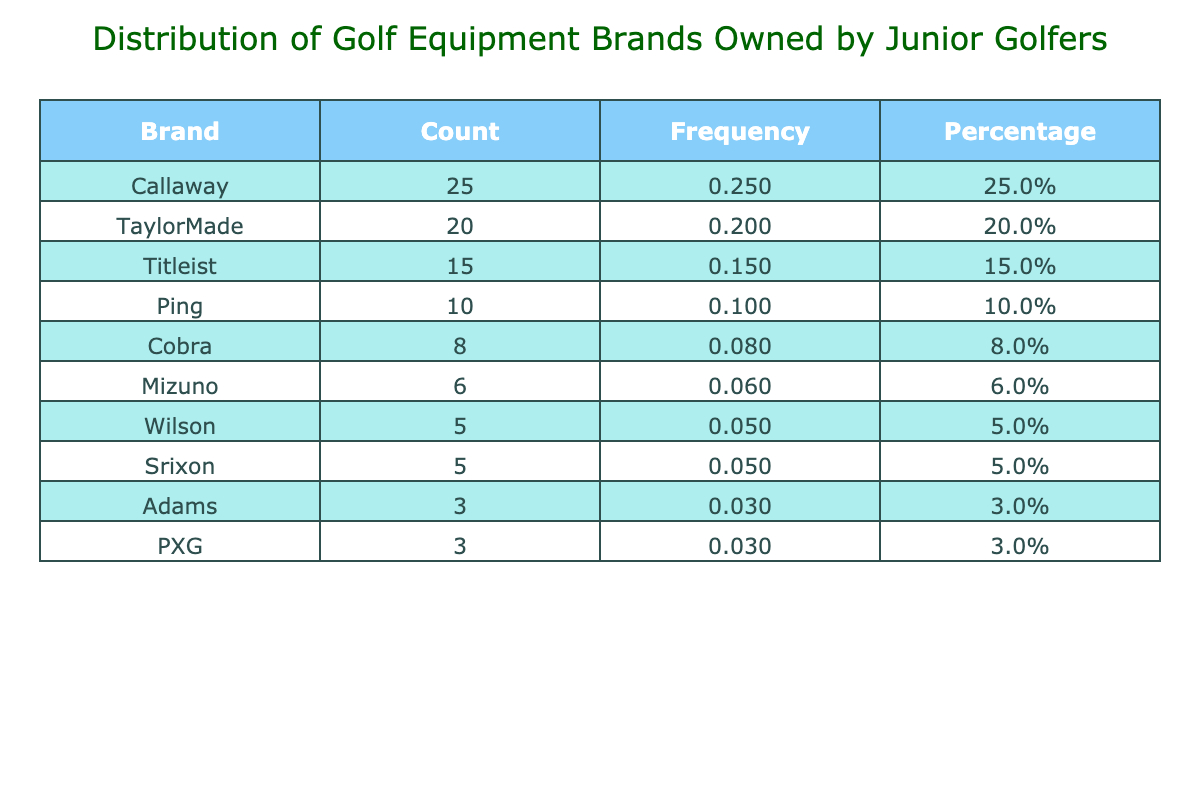What is the most popular brand of golf equipment owned by junior golfers? The table shows that Callaway has the highest count of 25, indicating it is the most popular brand among junior golfers.
Answer: Callaway How many junior golfers own Ping equipment? According to the table, the count for the Ping brand is 10, which means 10 junior golfers own Ping equipment.
Answer: 10 What percentage of junior golfers own TaylorMade equipment? The table states that the count for TaylorMade is 20. First, we find the total count of all brands, which is 25 + 20 + 15 + 10 + 8 + 6 + 5 + 5 + 3 + 3 =  100. Then, to find the percentage, we calculate (20 / 100) * 100 = 20%.
Answer: 20.0% Which brand has the lowest count of ownership among junior golfers? By examining the table, we see that Adams and PXG both have a count of 3, which is the lowest ownership count.
Answer: Adams and PXG What is the total count of golf equipment brands owned by junior golfers that are named Cobra and Mizuno combined? The count for Cobra is 8 and for Mizuno is 6. Adding these counts together gives us 8 + 6 = 14. Therefore, the total count for both brands combined is 14.
Answer: 14 Is the percentage of junior golfers owning Wilson equipment greater than that for Srixon equipment? From the table, Wilson has a count of 5 and Srixon also has a count of 5. To find their percentages, both percentages would be (5 / 100) * 100 = 5%. Since both percentages are equal, the statement is false.
Answer: No What is the average count of equipment owned for the three most popular brands? The three most popular brands are Callaway (25), TaylorMade (20), and Titleist (15). To find the average, we sum these counts: 25 + 20 + 15 = 60. Then, divide by 3 (the number of brands): 60 / 3 = 20.
Answer: 20 Are there more junior golfers who own Cobra equipment than those who own Adams equipment? Cobra has a count of 8, while Adams has a count of 3. Since 8 is greater than 3, it is true that more junior golfers own Cobra equipment than Adams.
Answer: Yes What is the total count of golf equipment owned for brands that have counts of 5 or below? The brands with counts of 5 or below are Wilson (5), Srixon (5), Adams (3), and PXG (3). Adding these counts together: 5 + 5 + 3 + 3 = 16 gives us the total count for these brands.
Answer: 16 